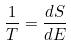<formula> <loc_0><loc_0><loc_500><loc_500>\frac { 1 } { T } = \frac { d S } { d E }</formula> 